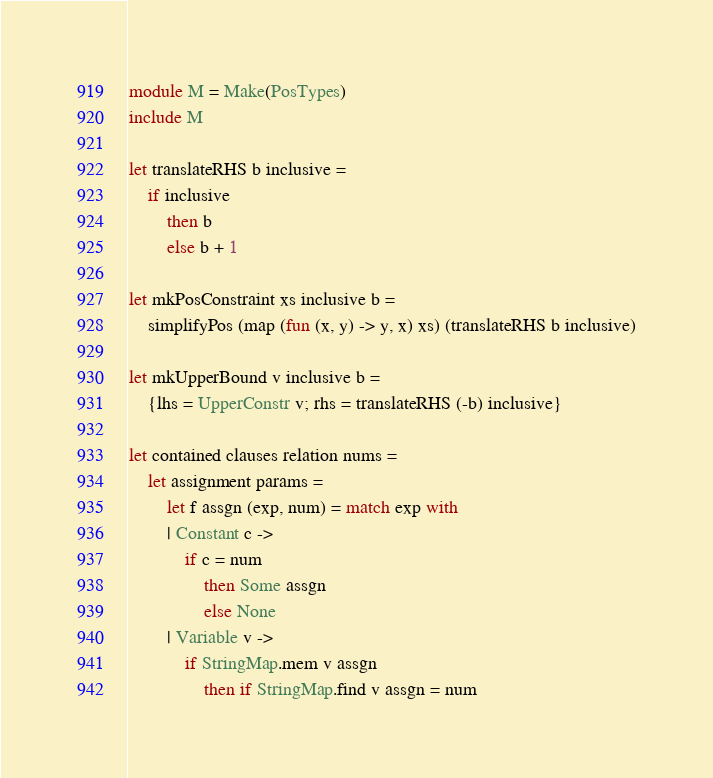Convert code to text. <code><loc_0><loc_0><loc_500><loc_500><_OCaml_>module M = Make(PosTypes)
include M

let translateRHS b inclusive =
	if inclusive
		then b
		else b + 1

let mkPosConstraint xs inclusive b =
	simplifyPos (map (fun (x, y) -> y, x) xs) (translateRHS b inclusive)

let mkUpperBound v inclusive b =
	{lhs = UpperConstr v; rhs = translateRHS (-b) inclusive}

let contained clauses relation nums =
	let assignment params =
		let f assgn (exp, num) = match exp with
		| Constant c ->
			if c = num
				then Some assgn
				else None
		| Variable v ->
			if StringMap.mem v assgn
				then if StringMap.find v assgn = num</code> 